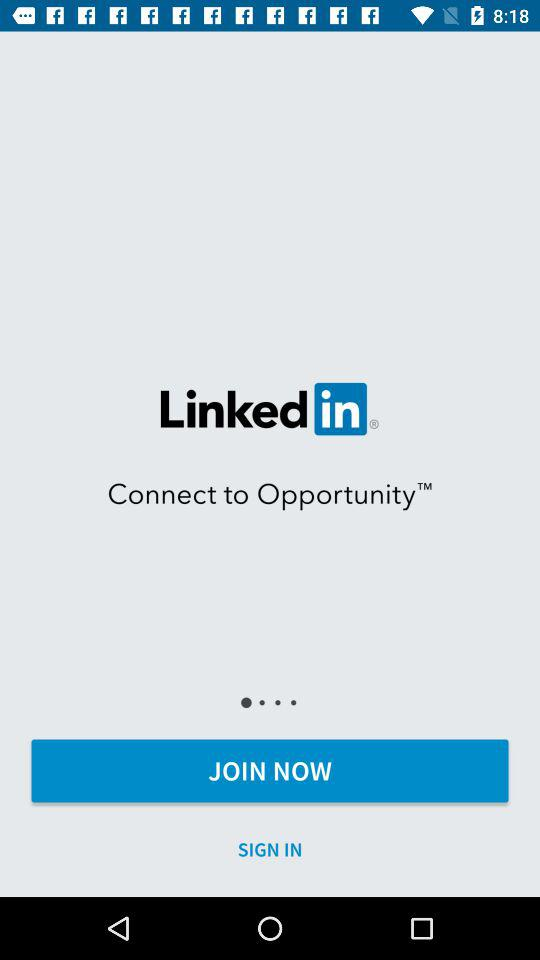What is the application name? The application name is "Linked in". 